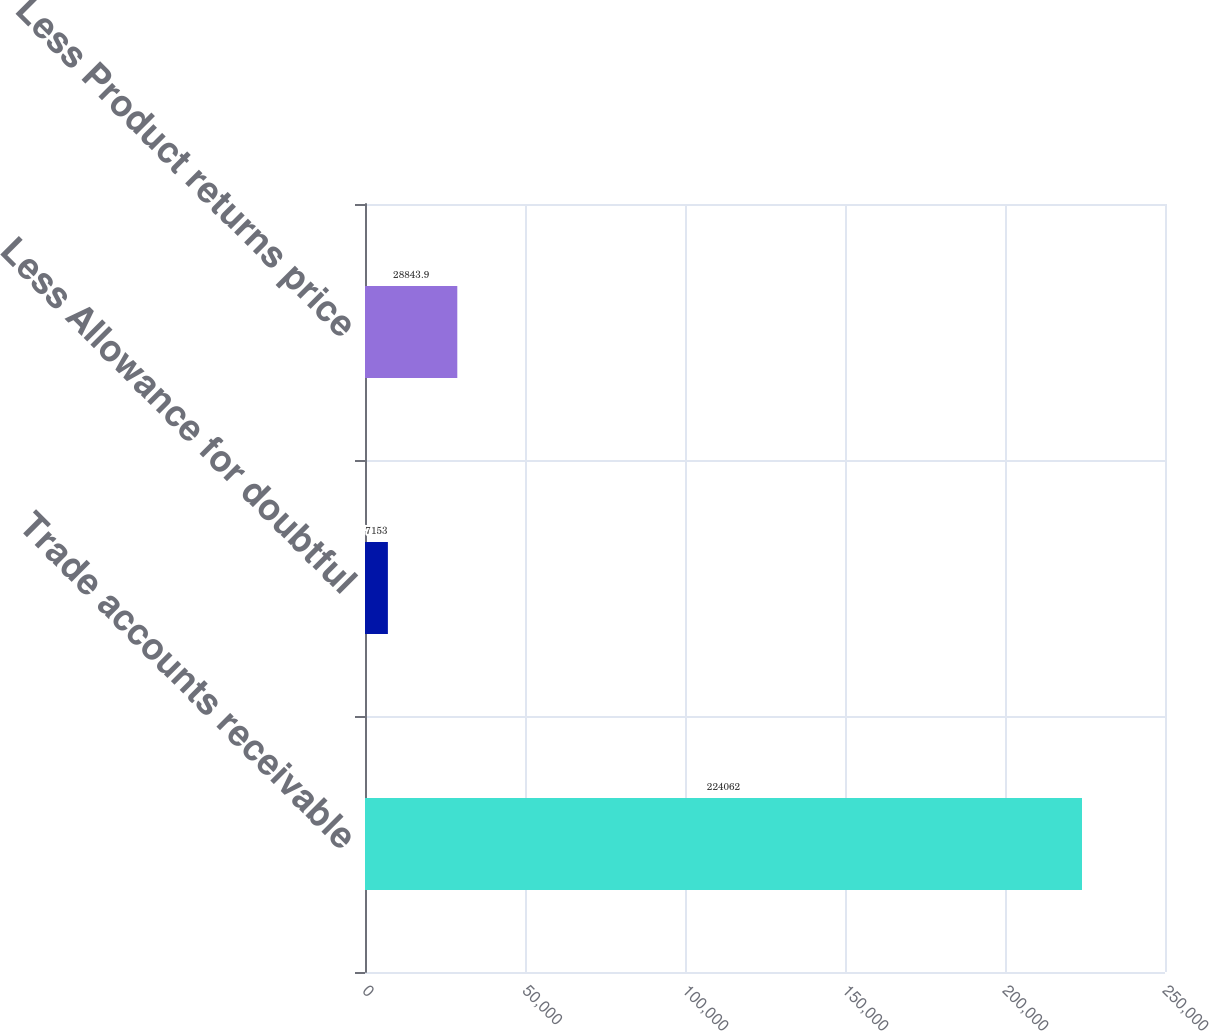<chart> <loc_0><loc_0><loc_500><loc_500><bar_chart><fcel>Trade accounts receivable<fcel>Less Allowance for doubtful<fcel>Less Product returns price<nl><fcel>224062<fcel>7153<fcel>28843.9<nl></chart> 